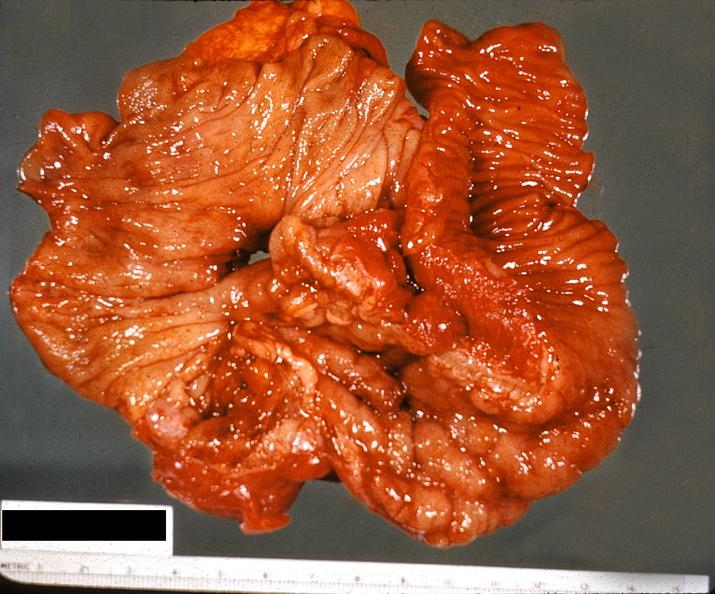does adrenal show ileum, regional enteritis?
Answer the question using a single word or phrase. No 